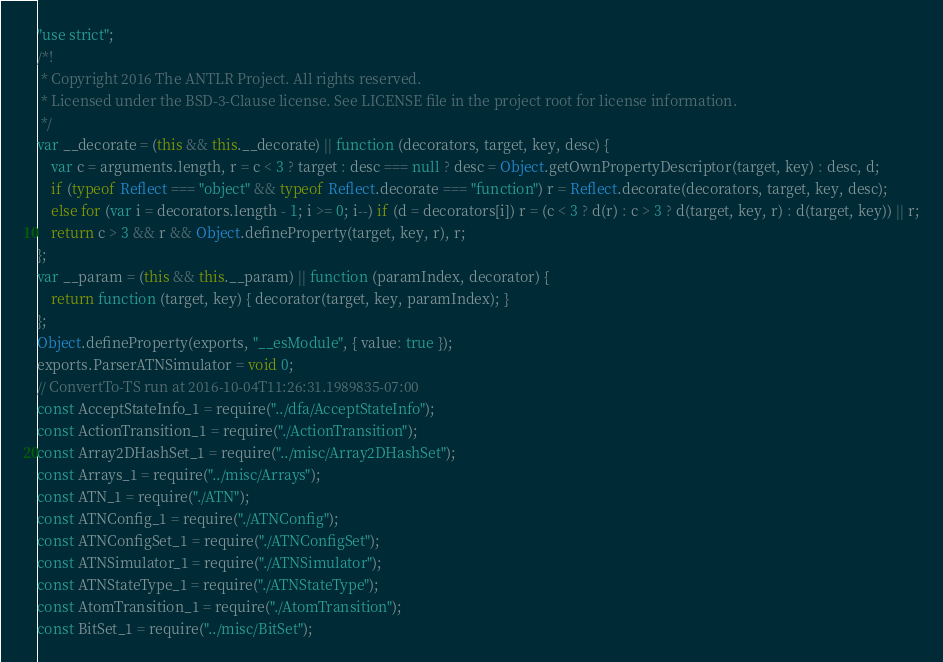Convert code to text. <code><loc_0><loc_0><loc_500><loc_500><_JavaScript_>"use strict";
/*!
 * Copyright 2016 The ANTLR Project. All rights reserved.
 * Licensed under the BSD-3-Clause license. See LICENSE file in the project root for license information.
 */
var __decorate = (this && this.__decorate) || function (decorators, target, key, desc) {
    var c = arguments.length, r = c < 3 ? target : desc === null ? desc = Object.getOwnPropertyDescriptor(target, key) : desc, d;
    if (typeof Reflect === "object" && typeof Reflect.decorate === "function") r = Reflect.decorate(decorators, target, key, desc);
    else for (var i = decorators.length - 1; i >= 0; i--) if (d = decorators[i]) r = (c < 3 ? d(r) : c > 3 ? d(target, key, r) : d(target, key)) || r;
    return c > 3 && r && Object.defineProperty(target, key, r), r;
};
var __param = (this && this.__param) || function (paramIndex, decorator) {
    return function (target, key) { decorator(target, key, paramIndex); }
};
Object.defineProperty(exports, "__esModule", { value: true });
exports.ParserATNSimulator = void 0;
// ConvertTo-TS run at 2016-10-04T11:26:31.1989835-07:00
const AcceptStateInfo_1 = require("../dfa/AcceptStateInfo");
const ActionTransition_1 = require("./ActionTransition");
const Array2DHashSet_1 = require("../misc/Array2DHashSet");
const Arrays_1 = require("../misc/Arrays");
const ATN_1 = require("./ATN");
const ATNConfig_1 = require("./ATNConfig");
const ATNConfigSet_1 = require("./ATNConfigSet");
const ATNSimulator_1 = require("./ATNSimulator");
const ATNStateType_1 = require("./ATNStateType");
const AtomTransition_1 = require("./AtomTransition");
const BitSet_1 = require("../misc/BitSet");</code> 